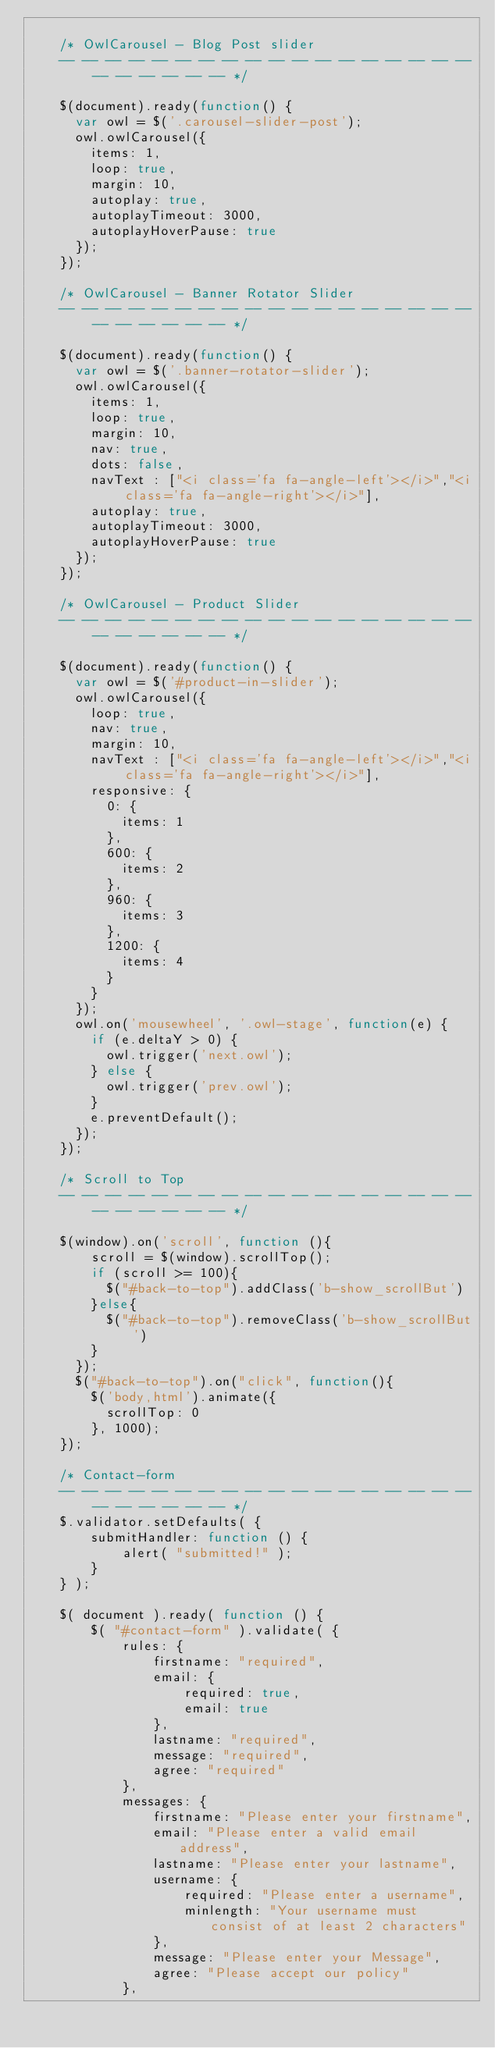Convert code to text. <code><loc_0><loc_0><loc_500><loc_500><_JavaScript_>		
	/* OwlCarousel - Blog Post slider
	-- -- -- -- -- -- -- -- -- -- -- -- -- -- -- -- -- -- -- -- -- -- -- -- */
	
	$(document).ready(function() {
	  var owl = $('.carousel-slider-post');
	  owl.owlCarousel({
		items: 1,
		loop: true,
		margin: 10,
		autoplay: true,
		autoplayTimeout: 3000,
		autoplayHoverPause: true
	  });	  
	});
	
	/* OwlCarousel - Banner Rotator Slider
	-- -- -- -- -- -- -- -- -- -- -- -- -- -- -- -- -- -- -- -- -- -- -- -- */
	
	$(document).ready(function() {
	  var owl = $('.banner-rotator-slider');
	  owl.owlCarousel({
		items: 1,
		loop: true,
		margin: 10,
		nav: true,
		dots: false,
		navText : ["<i class='fa fa-angle-left'></i>","<i class='fa fa-angle-right'></i>"],
		autoplay: true,
		autoplayTimeout: 3000,
		autoplayHoverPause: true
	  });	  
	});
	
	/* OwlCarousel - Product Slider
	-- -- -- -- -- -- -- -- -- -- -- -- -- -- -- -- -- -- -- -- -- -- -- -- */
	
	$(document).ready(function() {
	  var owl = $('#product-in-slider');
	  owl.owlCarousel({
		loop: true,
		nav: true,
		margin: 10,
		navText : ["<i class='fa fa-angle-left'></i>","<i class='fa fa-angle-right'></i>"],
		responsive: {
		  0: {
			items: 1
		  },
		  600: {
			items: 2
		  },
		  960: {
			items: 3
		  },
		  1200: {
			items: 4
		  }
		}
	  });
	  owl.on('mousewheel', '.owl-stage', function(e) {
		if (e.deltaY > 0) {
		  owl.trigger('next.owl');
		} else {
		  owl.trigger('prev.owl');
		}
		e.preventDefault();
	  });
	});
	
	/* Scroll to Top
	-- -- -- -- -- -- -- -- -- -- -- -- -- -- -- -- -- -- -- -- -- -- -- -- */
	
	$(window).on('scroll', function (){
        scroll = $(window).scrollTop();
        if (scroll >= 100){
          $("#back-to-top").addClass('b-show_scrollBut')
        }else{
          $("#back-to-top").removeClass('b-show_scrollBut')
        }
      });
      $("#back-to-top").on("click", function(){
        $('body,html').animate({
          scrollTop: 0
        }, 1000);
    });
	
	/* Contact-form
	-- -- -- -- -- -- -- -- -- -- -- -- -- -- -- -- -- -- -- -- -- -- -- -- */
	$.validator.setDefaults( {
		submitHandler: function () {
			alert( "submitted!" );
		}
	} );
	
	$( document ).ready( function () {
		$( "#contact-form" ).validate( {
			rules: {
				firstname: "required",
				email: {
					required: true,
					email: true
				},
				lastname: "required",
				message: "required",
				agree: "required"
			},
			messages: {
				firstname: "Please enter your firstname",
				email: "Please enter a valid email address",
				lastname: "Please enter your lastname",
				username: {
					required: "Please enter a username",
					minlength: "Your username must consist of at least 2 characters"
				},
				message: "Please enter your Message",
				agree: "Please accept our policy"
			},</code> 